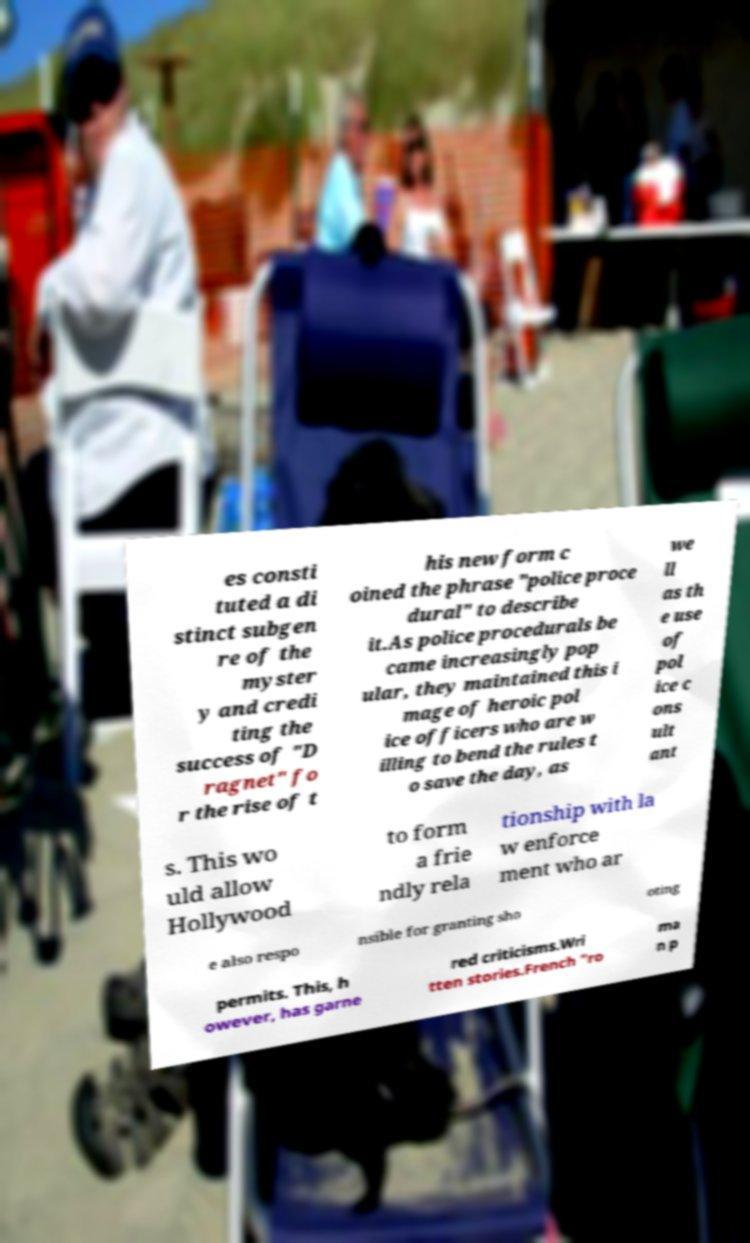Could you assist in decoding the text presented in this image and type it out clearly? es consti tuted a di stinct subgen re of the myster y and credi ting the success of "D ragnet" fo r the rise of t his new form c oined the phrase "police proce dural" to describe it.As police procedurals be came increasingly pop ular, they maintained this i mage of heroic pol ice officers who are w illing to bend the rules t o save the day, as we ll as th e use of pol ice c ons ult ant s. This wo uld allow Hollywood to form a frie ndly rela tionship with la w enforce ment who ar e also respo nsible for granting sho oting permits. This, h owever, has garne red criticisms.Wri tten stories.French "ro ma n p 